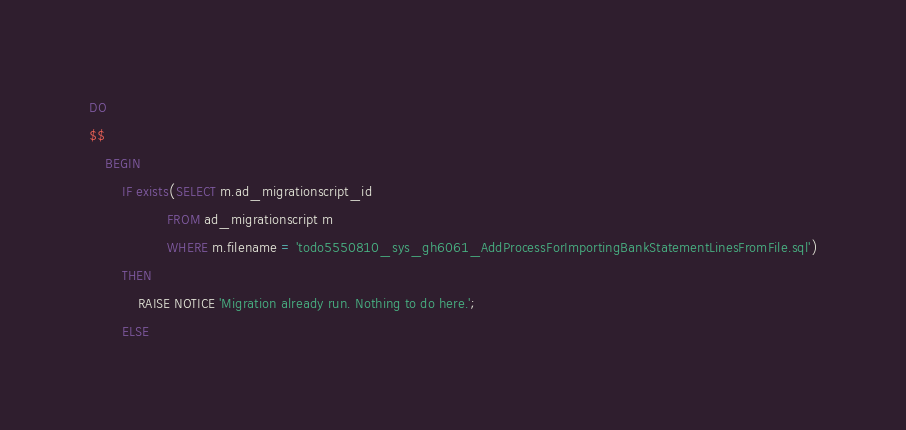Convert code to text. <code><loc_0><loc_0><loc_500><loc_500><_SQL_>DO
$$
    BEGIN
        IF exists(SELECT m.ad_migrationscript_id
                   FROM ad_migrationscript m
                   WHERE m.filename = 'todo5550810_sys_gh6061_AddProcessForImportingBankStatementLinesFromFile.sql')
        THEN
            RAISE NOTICE 'Migration already run. Nothing to do here.';
        ELSE</code> 